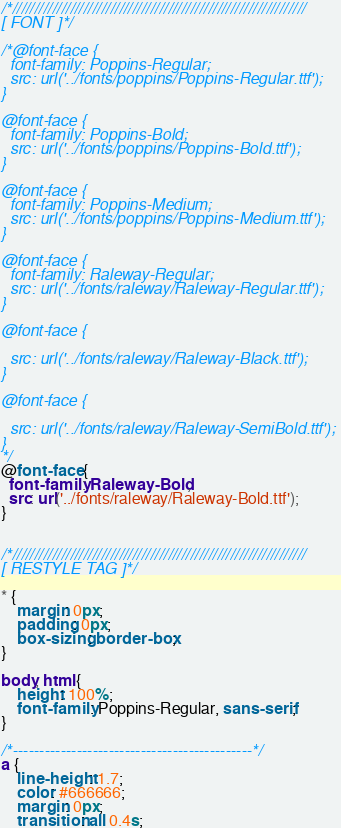<code> <loc_0><loc_0><loc_500><loc_500><_CSS_>/*//////////////////////////////////////////////////////////////////
[ FONT ]*/

/*@font-face {
  font-family: Poppins-Regular;
  src: url('../fonts/poppins/Poppins-Regular.ttf'); 
}

@font-face {
  font-family: Poppins-Bold;
  src: url('../fonts/poppins/Poppins-Bold.ttf'); 
}

@font-face {
  font-family: Poppins-Medium;
  src: url('../fonts/poppins/Poppins-Medium.ttf'); 
}

@font-face {
  font-family: Raleway-Regular;
  src: url('../fonts/raleway/Raleway-Regular.ttf'); 
}

@font-face {
  
  src: url('../fonts/raleway/Raleway-Black.ttf'); 
}

@font-face {
  
  src: url('../fonts/raleway/Raleway-SemiBold.ttf'); 
}
*/
@font-face {
  font-family: Raleway-Bold;
  src: url('../fonts/raleway/Raleway-Bold.ttf'); 
}


/*//////////////////////////////////////////////////////////////////
[ RESTYLE TAG ]*/

* {
	margin: 0px; 
	padding: 0px; 
	box-sizing: border-box;
}

body, html {
	height: 100%;
	font-family: Poppins-Regular, sans-serif;
}

/*---------------------------------------------*/
a {
	line-height: 1.7;
	color: #666666;
	margin: 0px;
	transition: all 0.4s;</code> 